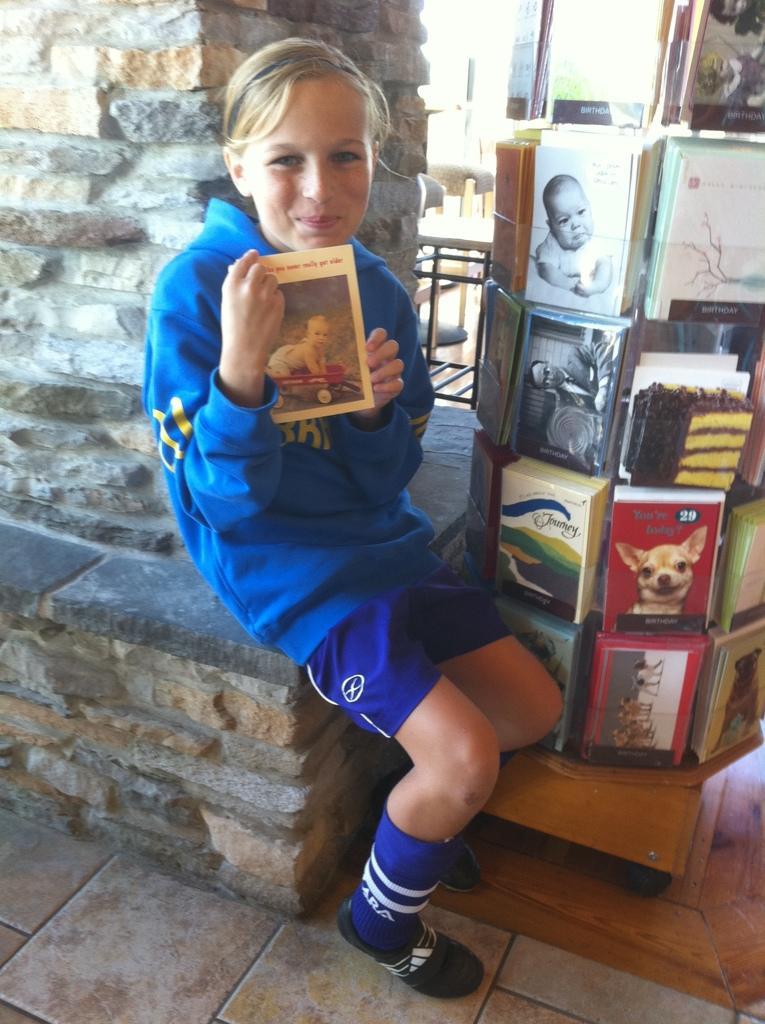Describe this image in one or two sentences. In this image there is a girl sitting and holding a book in her hand, inside her there is a stand, in that stand there are books, behind her there is a pillar. 